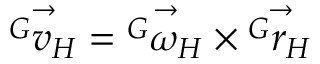<formula> <loc_0><loc_0><loc_500><loc_500>\vec { { ^ { G } } v _ { H } } = \vec { { ^ { G } } \omega _ { H } } \times \vec { { ^ { G } } r _ { H } }</formula> 